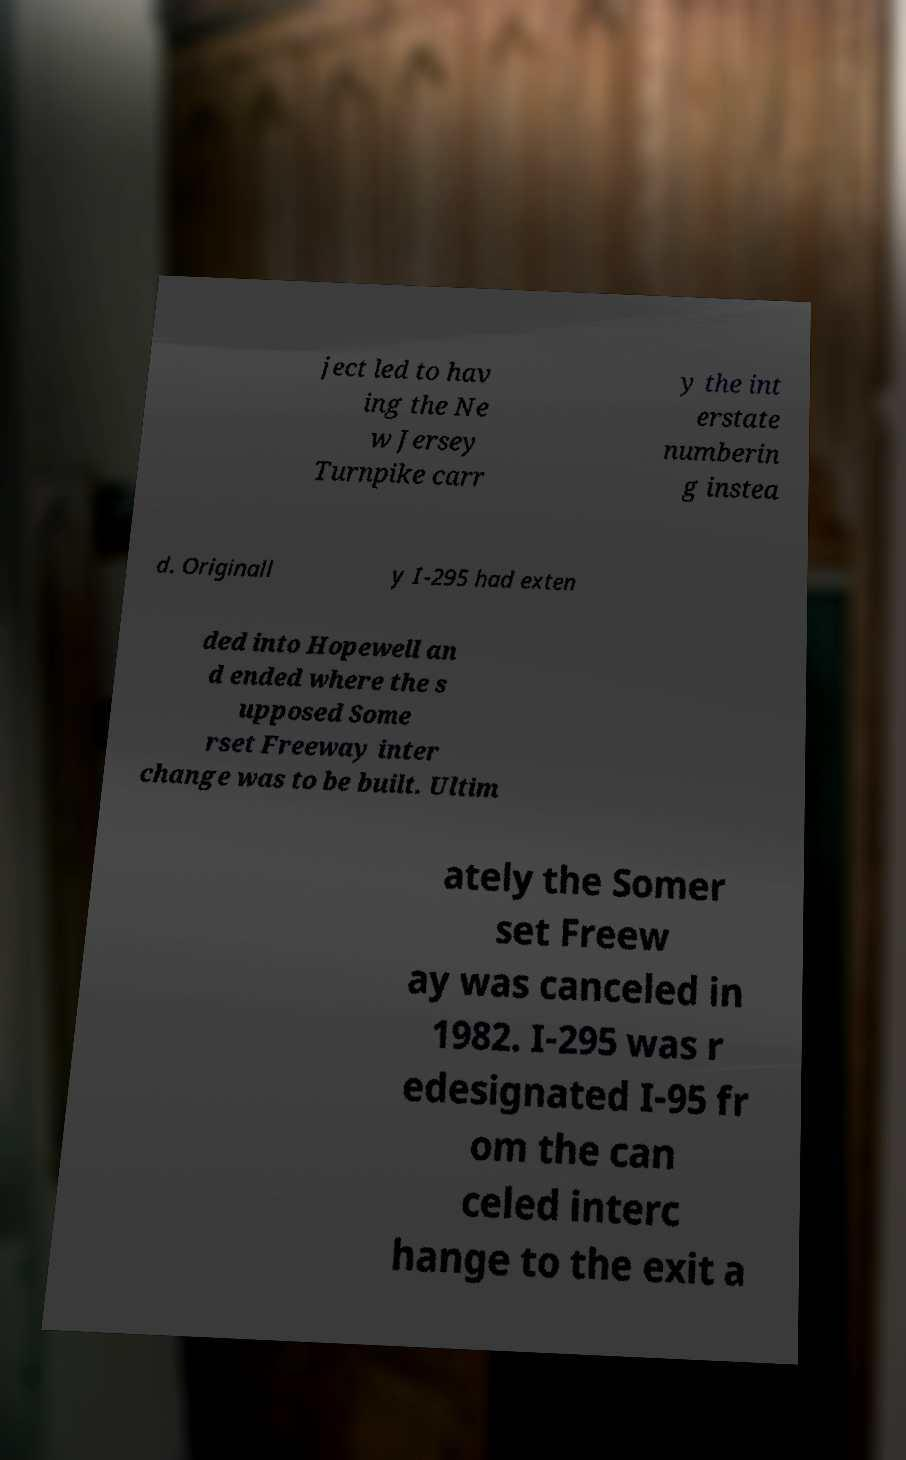There's text embedded in this image that I need extracted. Can you transcribe it verbatim? ject led to hav ing the Ne w Jersey Turnpike carr y the int erstate numberin g instea d. Originall y I-295 had exten ded into Hopewell an d ended where the s upposed Some rset Freeway inter change was to be built. Ultim ately the Somer set Freew ay was canceled in 1982. I-295 was r edesignated I-95 fr om the can celed interc hange to the exit a 